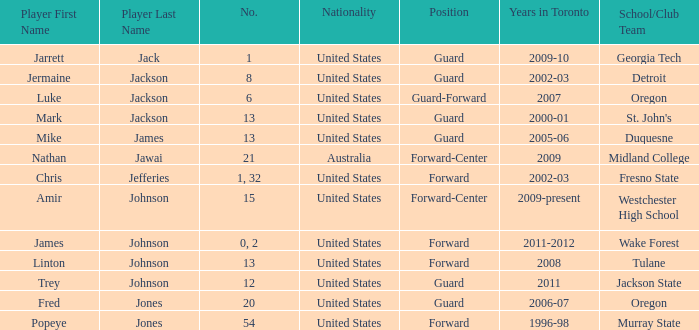Can you give me this table as a dict? {'header': ['Player First Name', 'Player Last Name', 'No.', 'Nationality', 'Position', 'Years in Toronto', 'School/Club Team'], 'rows': [['Jarrett', 'Jack', '1', 'United States', 'Guard', '2009-10', 'Georgia Tech'], ['Jermaine', 'Jackson', '8', 'United States', 'Guard', '2002-03', 'Detroit'], ['Luke', 'Jackson', '6', 'United States', 'Guard-Forward', '2007', 'Oregon'], ['Mark', 'Jackson', '13', 'United States', 'Guard', '2000-01', "St. John's"], ['Mike', 'James', '13', 'United States', 'Guard', '2005-06', 'Duquesne'], ['Nathan', 'Jawai', '21', 'Australia', 'Forward-Center', '2009', 'Midland College'], ['Chris', 'Jefferies', '1, 32', 'United States', 'Forward', '2002-03', 'Fresno State'], ['Amir', 'Johnson', '15', 'United States', 'Forward-Center', '2009-present', 'Westchester High School'], ['James', 'Johnson', '0, 2', 'United States', 'Forward', '2011-2012', 'Wake Forest'], ['Linton', 'Johnson', '13', 'United States', 'Forward', '2008', 'Tulane'], ['Trey', 'Johnson', '12', 'United States', 'Guard', '2011', 'Jackson State'], ['Fred', 'Jones', '20', 'United States', 'Guard', '2006-07', 'Oregon'], ['Popeye', 'Jones', '54', 'United States', 'Forward', '1996-98', 'Murray State']]} What school/club team is Amir Johnson on? Westchester High School. 